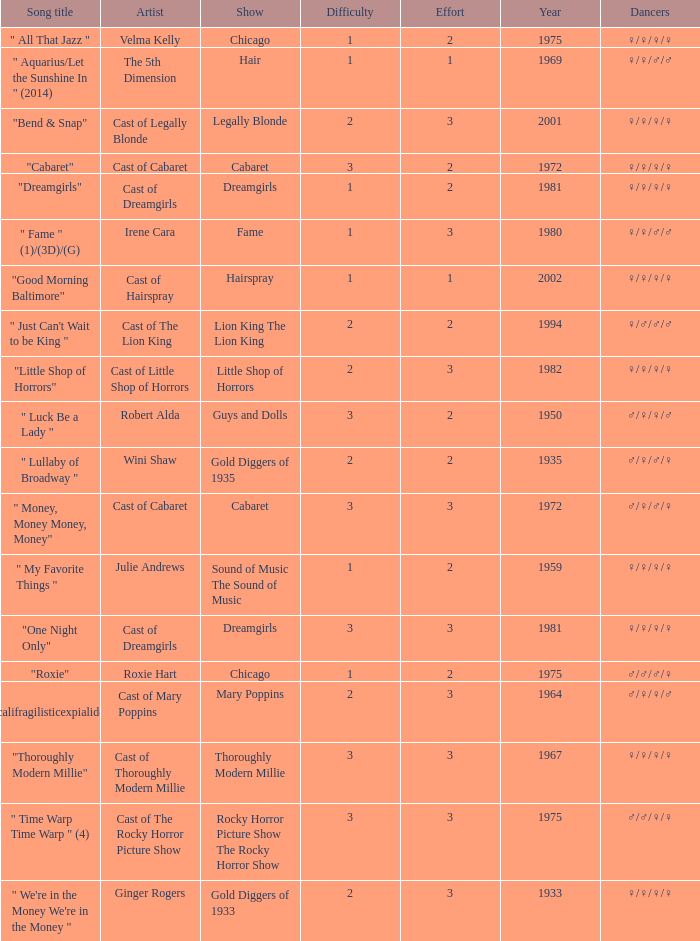What was the total number of artists involved in the show thoroughly modern millie? 1.0. Could you parse the entire table as a dict? {'header': ['Song title', 'Artist', 'Show', 'Difficulty', 'Effort', 'Year', 'Dancers'], 'rows': [['" All That Jazz "', 'Velma Kelly', 'Chicago', '1', '2', '1975', '♀/♀/♀/♀'], ['" Aquarius/Let the Sunshine In " (2014)', 'The 5th Dimension', 'Hair', '1', '1', '1969', '♀/♀/♂/♂'], ['"Bend & Snap"', 'Cast of Legally Blonde', 'Legally Blonde', '2', '3', '2001', '♀/♀/♀/♀'], ['"Cabaret"', 'Cast of Cabaret', 'Cabaret', '3', '2', '1972', '♀/♀/♀/♀'], ['"Dreamgirls"', 'Cast of Dreamgirls', 'Dreamgirls', '1', '2', '1981', '♀/♀/♀/♀'], ['" Fame " (1)/(3D)/(G)', 'Irene Cara', 'Fame', '1', '3', '1980', '♀/♀/♂/♂'], ['"Good Morning Baltimore"', 'Cast of Hairspray', 'Hairspray', '1', '1', '2002', '♀/♀/♀/♀'], ['" Just Can\'t Wait to be King "', 'Cast of The Lion King', 'Lion King The Lion King', '2', '2', '1994', '♀/♂/♂/♂'], ['"Little Shop of Horrors"', 'Cast of Little Shop of Horrors', 'Little Shop of Horrors', '2', '3', '1982', '♀/♀/♀/♀'], ['" Luck Be a Lady "', 'Robert Alda', 'Guys and Dolls', '3', '2', '1950', '♂/♀/♀/♂'], ['" Lullaby of Broadway "', 'Wini Shaw', 'Gold Diggers of 1935', '2', '2', '1935', '♂/♀/♂/♀'], ['" Money, Money Money, Money"', 'Cast of Cabaret', 'Cabaret', '3', '3', '1972', '♂/♀/♂/♀'], ['" My Favorite Things "', 'Julie Andrews', 'Sound of Music The Sound of Music', '1', '2', '1959', '♀/♀/♀/♀'], ['"One Night Only"', 'Cast of Dreamgirls', 'Dreamgirls', '3', '3', '1981', '♀/♀/♀/♀'], ['"Roxie"', 'Roxie Hart', 'Chicago', '1', '2', '1975', '♂/♂/♂/♀'], ['" Supercalifragilisticexpialidocious " (DP)', 'Cast of Mary Poppins', 'Mary Poppins', '2', '3', '1964', '♂/♀/♀/♂'], ['"Thoroughly Modern Millie"', 'Cast of Thoroughly Modern Millie', 'Thoroughly Modern Millie', '3', '3', '1967', '♀/♀/♀/♀'], ['" Time Warp Time Warp " (4)', 'Cast of The Rocky Horror Picture Show', 'Rocky Horror Picture Show The Rocky Horror Show', '3', '3', '1975', '♂/♂/♀/♀'], ['" We\'re in the Money We\'re in the Money "', 'Ginger Rogers', 'Gold Diggers of 1933', '2', '3', '1933', '♀/♀/♀/♀']]} 